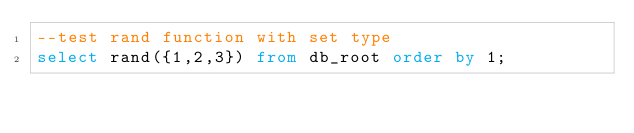Convert code to text. <code><loc_0><loc_0><loc_500><loc_500><_SQL_>--test rand function with set type
select rand({1,2,3}) from db_root order by 1;</code> 